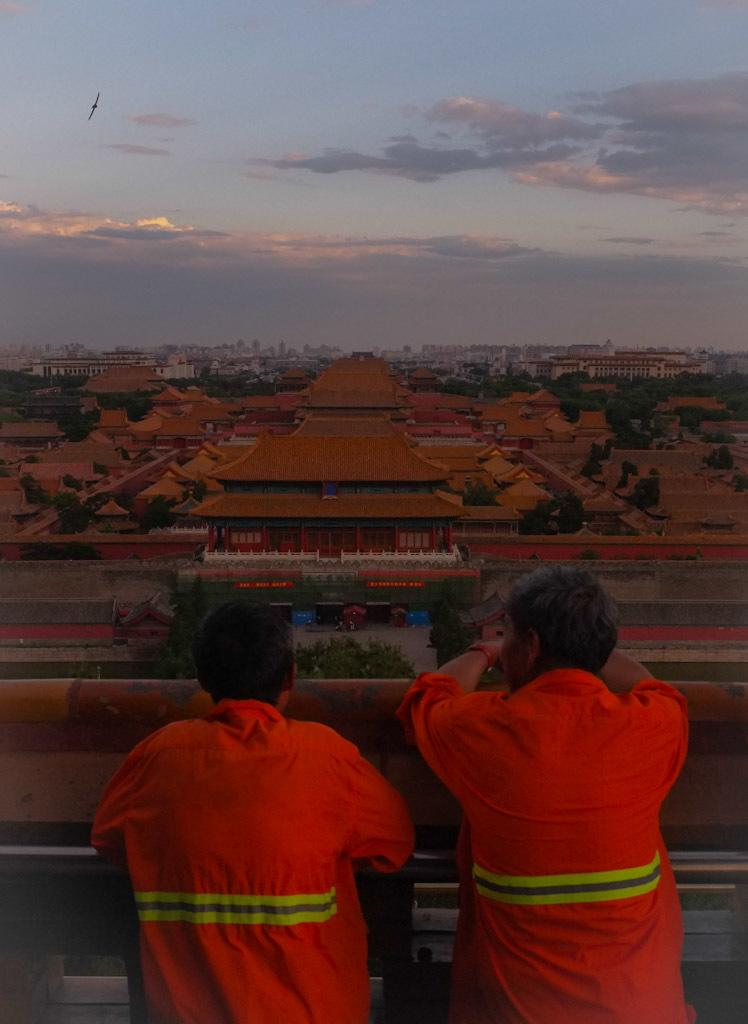Who are the two people near in the image? There are two people near a rod in the image. What can be seen in the background of the image? There are houses, trees, buildings, and walls in the background of the image. What is the condition of the sky in the image? The sky is cloudy at the top of the image. What is happening in the air in the image? A bird is flying in the air in the image. What type of holiday is being celebrated in the image? There is no indication of a holiday being celebrated in the image. Can you see a beetle crawling on the rod in the image? There is no beetle present in the image. 